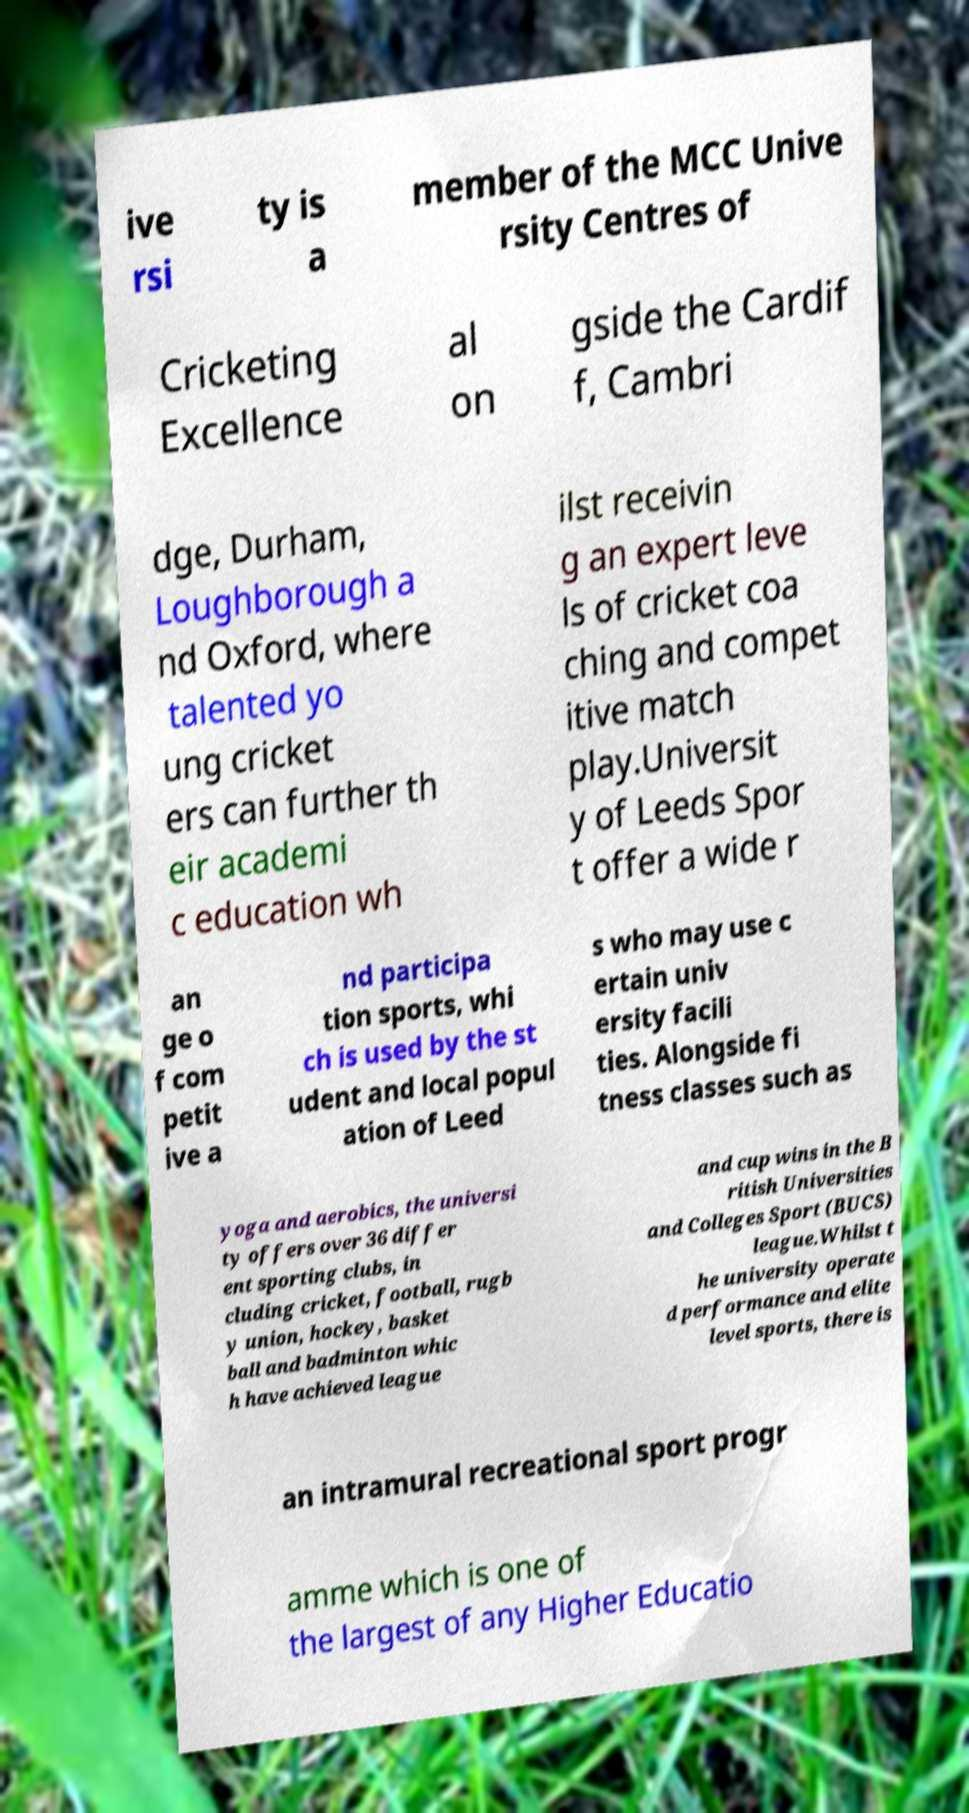Can you accurately transcribe the text from the provided image for me? ive rsi ty is a member of the MCC Unive rsity Centres of Cricketing Excellence al on gside the Cardif f, Cambri dge, Durham, Loughborough a nd Oxford, where talented yo ung cricket ers can further th eir academi c education wh ilst receivin g an expert leve ls of cricket coa ching and compet itive match play.Universit y of Leeds Spor t offer a wide r an ge o f com petit ive a nd participa tion sports, whi ch is used by the st udent and local popul ation of Leed s who may use c ertain univ ersity facili ties. Alongside fi tness classes such as yoga and aerobics, the universi ty offers over 36 differ ent sporting clubs, in cluding cricket, football, rugb y union, hockey, basket ball and badminton whic h have achieved league and cup wins in the B ritish Universities and Colleges Sport (BUCS) league.Whilst t he university operate d performance and elite level sports, there is an intramural recreational sport progr amme which is one of the largest of any Higher Educatio 